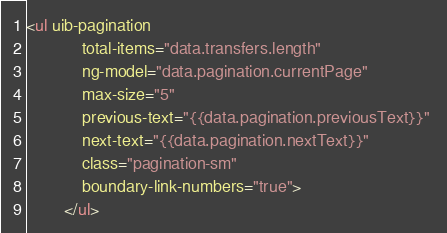Convert code to text. <code><loc_0><loc_0><loc_500><loc_500><_HTML_><ul uib-pagination 
            total-items="data.transfers.length" 
            ng-model="data.pagination.currentPage" 
            max-size="5" 
            previous-text="{{data.pagination.previousText}}" 
            next-text="{{data.pagination.nextText}}" 
            class="pagination-sm" 
            boundary-link-numbers="true">
        </ul></code> 